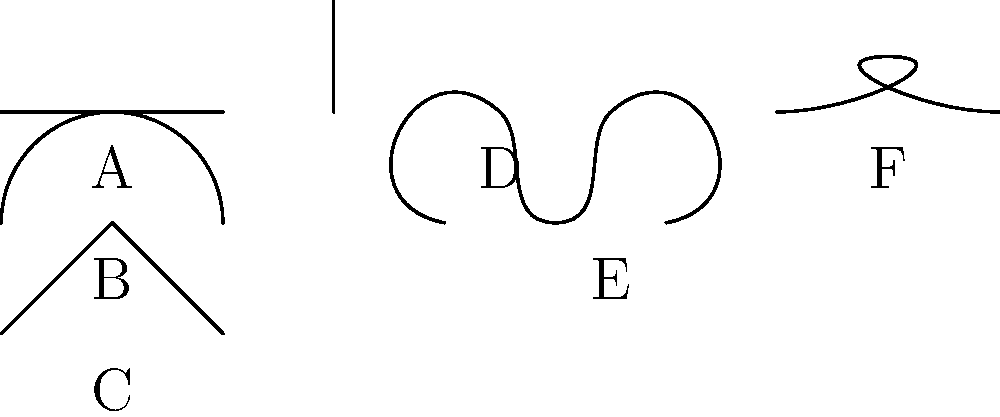Based on your experience with the cutting-edge medical procedure, identify the type of incision and suture technique that was used in your surgery. Match the correct labels (A-F) to the following descriptions:

1. Incision type used for better scar camouflage
2. Suture technique that provides a strong closure for high-tension areas
3. Incision type commonly used for appendectomies
4. Suture technique that results in minimal scarring Step 1: Analyze the incision types (A, B, C):
A: Linear incision - straight cut, commonly used for simple procedures
B: Curved incision - follows body contours, used for larger surgeries
C: Z-plasty incision - used for scar revision and better camouflage

Step 2: Analyze the suture techniques (D, E, F):
D: Interrupted suture - individual stitches, strong closure
E: Continuous suture - single thread, faster to place
F: Subcuticular suture - placed beneath the skin, minimal scarring

Step 3: Match the descriptions to the correct labels:
1. Z-plasty incision (C) is used for better scar camouflage
2. Interrupted suture (D) provides a strong closure for high-tension areas
3. Linear incision (A) is commonly used for appendectomies
4. Subcuticular suture (F) results in minimal scarring

Therefore, the correct matches are:
1. C
2. D
3. A
4. F
Answer: C, D, A, F 